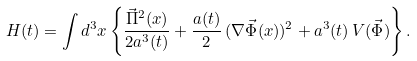Convert formula to latex. <formula><loc_0><loc_0><loc_500><loc_500>H ( t ) = \int d ^ { 3 } x \left \{ \frac { \vec { \Pi } ^ { 2 } ( x ) } { 2 a ^ { 3 } ( t ) } + \frac { a ( t ) } { 2 } \, ( \nabla \vec { \Phi } ( x ) ) ^ { 2 } + a ^ { 3 } ( t ) \, V ( \vec { \Phi } ) \right \} .</formula> 